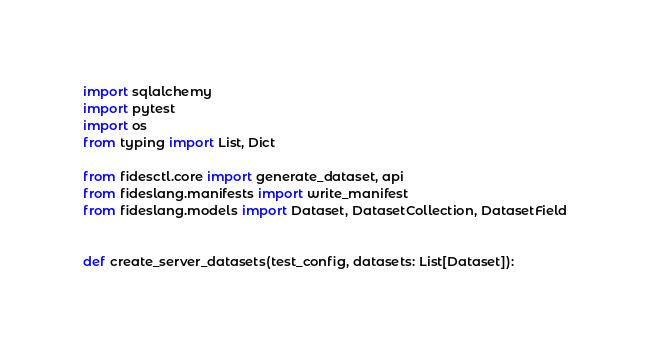Convert code to text. <code><loc_0><loc_0><loc_500><loc_500><_Python_>import sqlalchemy
import pytest
import os
from typing import List, Dict

from fidesctl.core import generate_dataset, api
from fideslang.manifests import write_manifest
from fideslang.models import Dataset, DatasetCollection, DatasetField


def create_server_datasets(test_config, datasets: List[Dataset]):</code> 